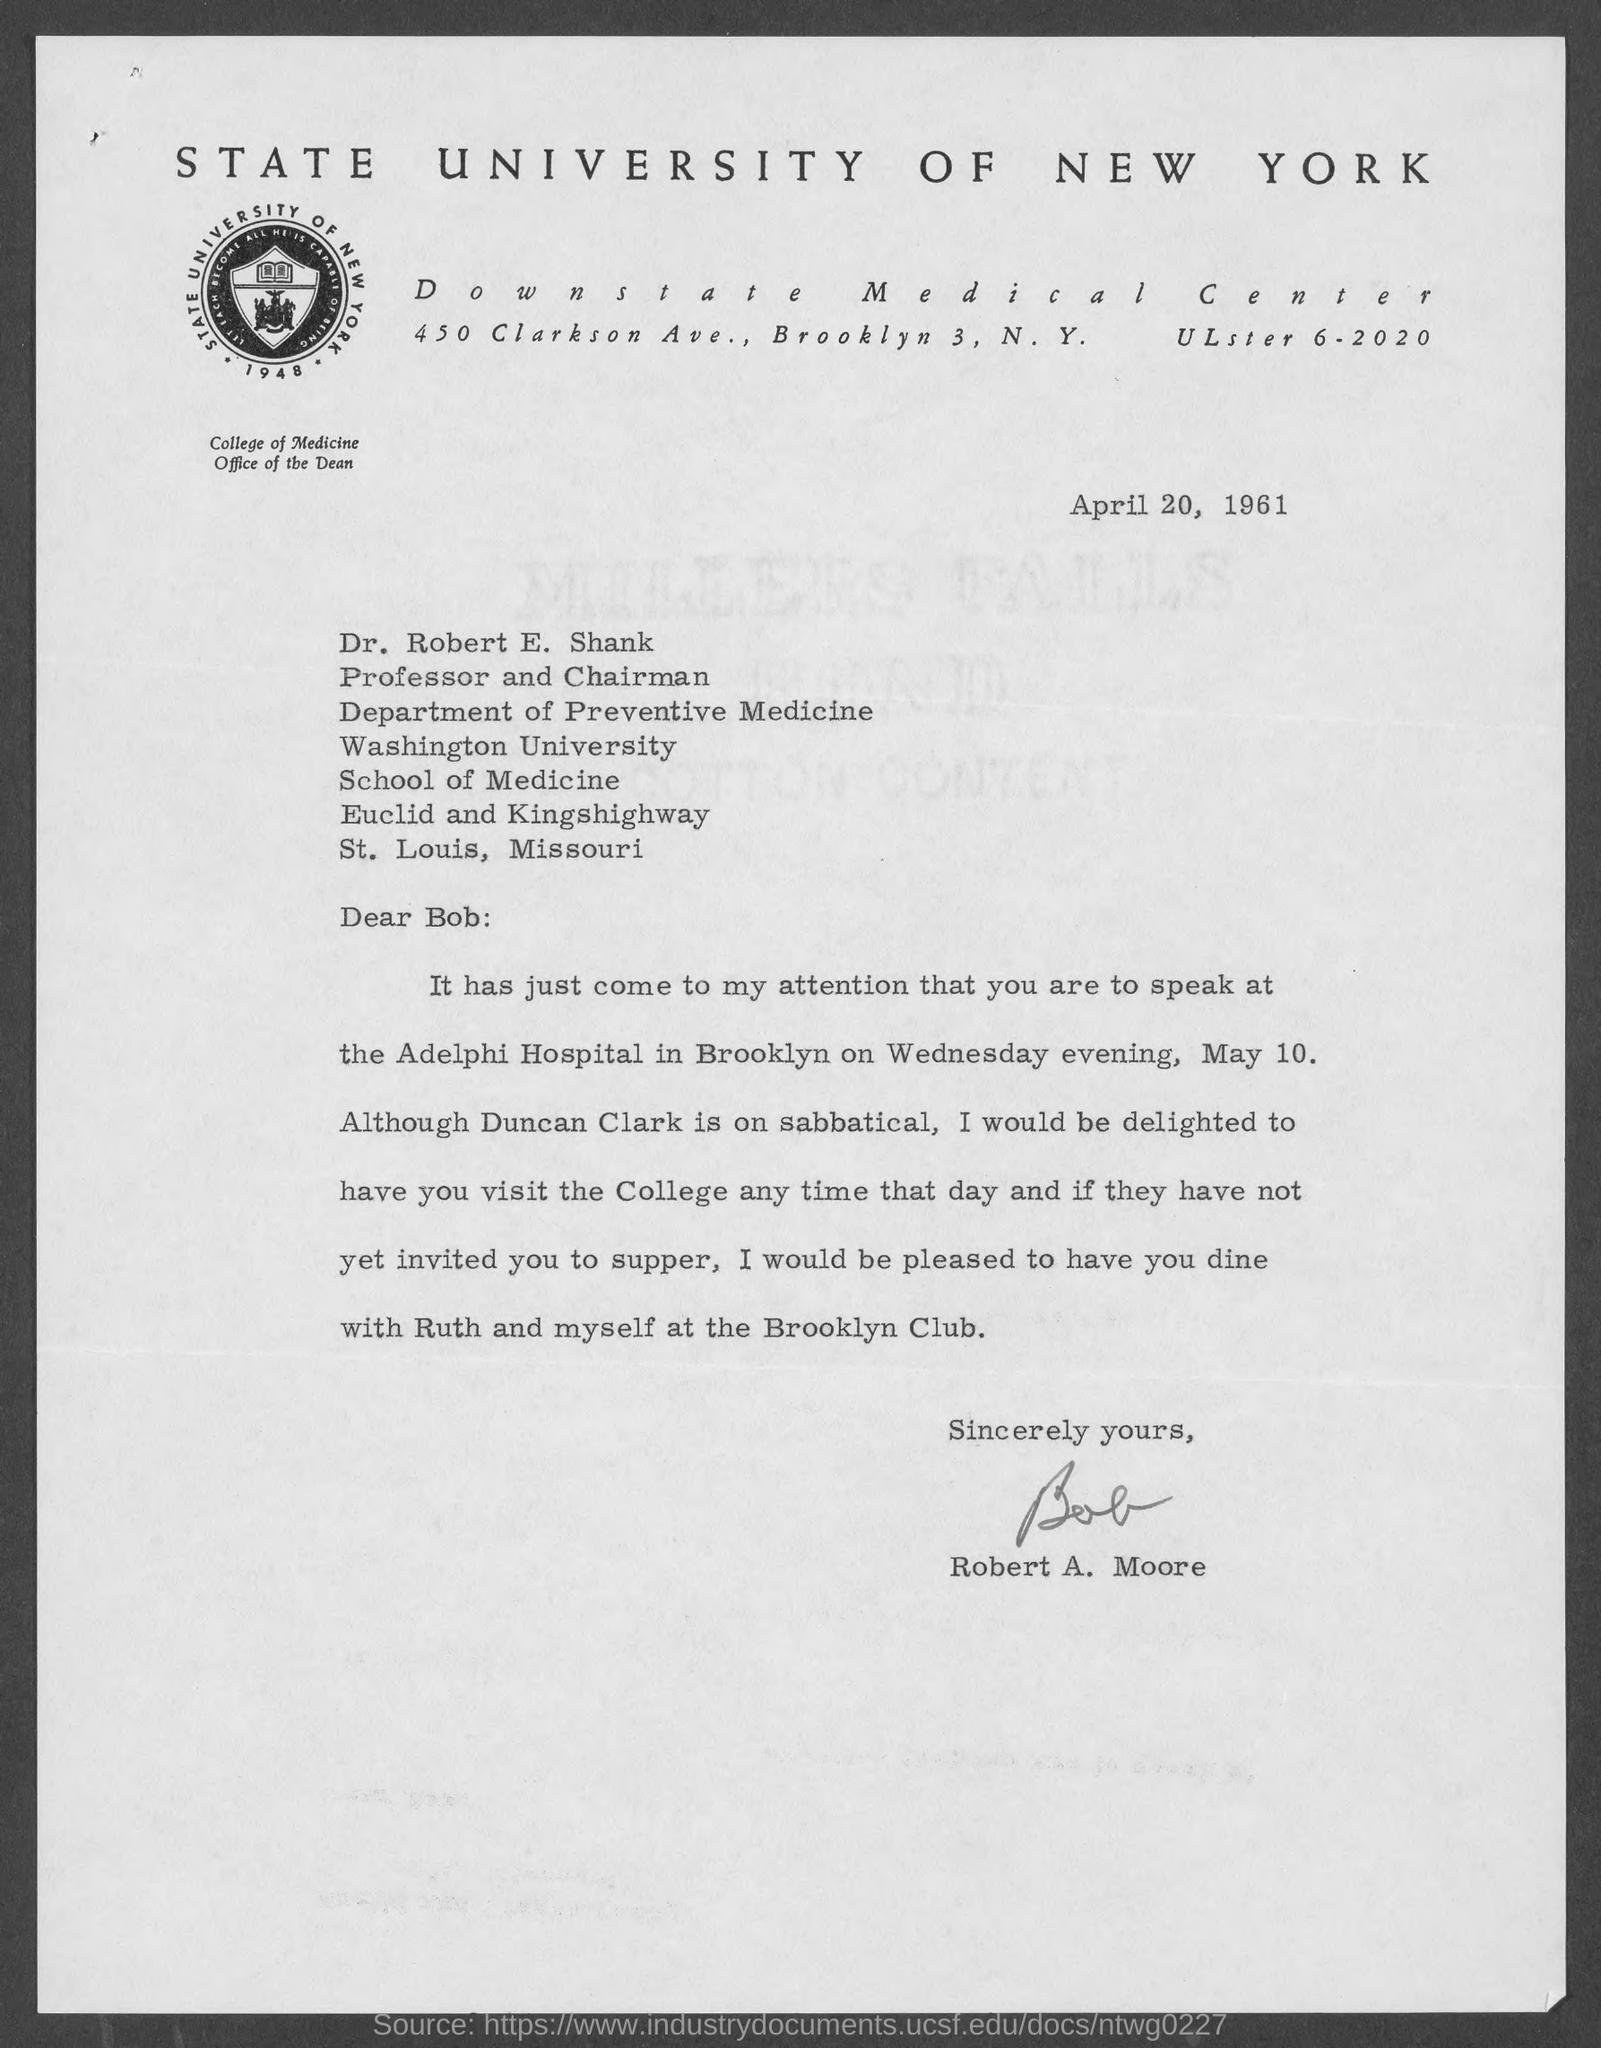Outline some significant characteristics in this image. The memorandum was dated April 20, 1961. 